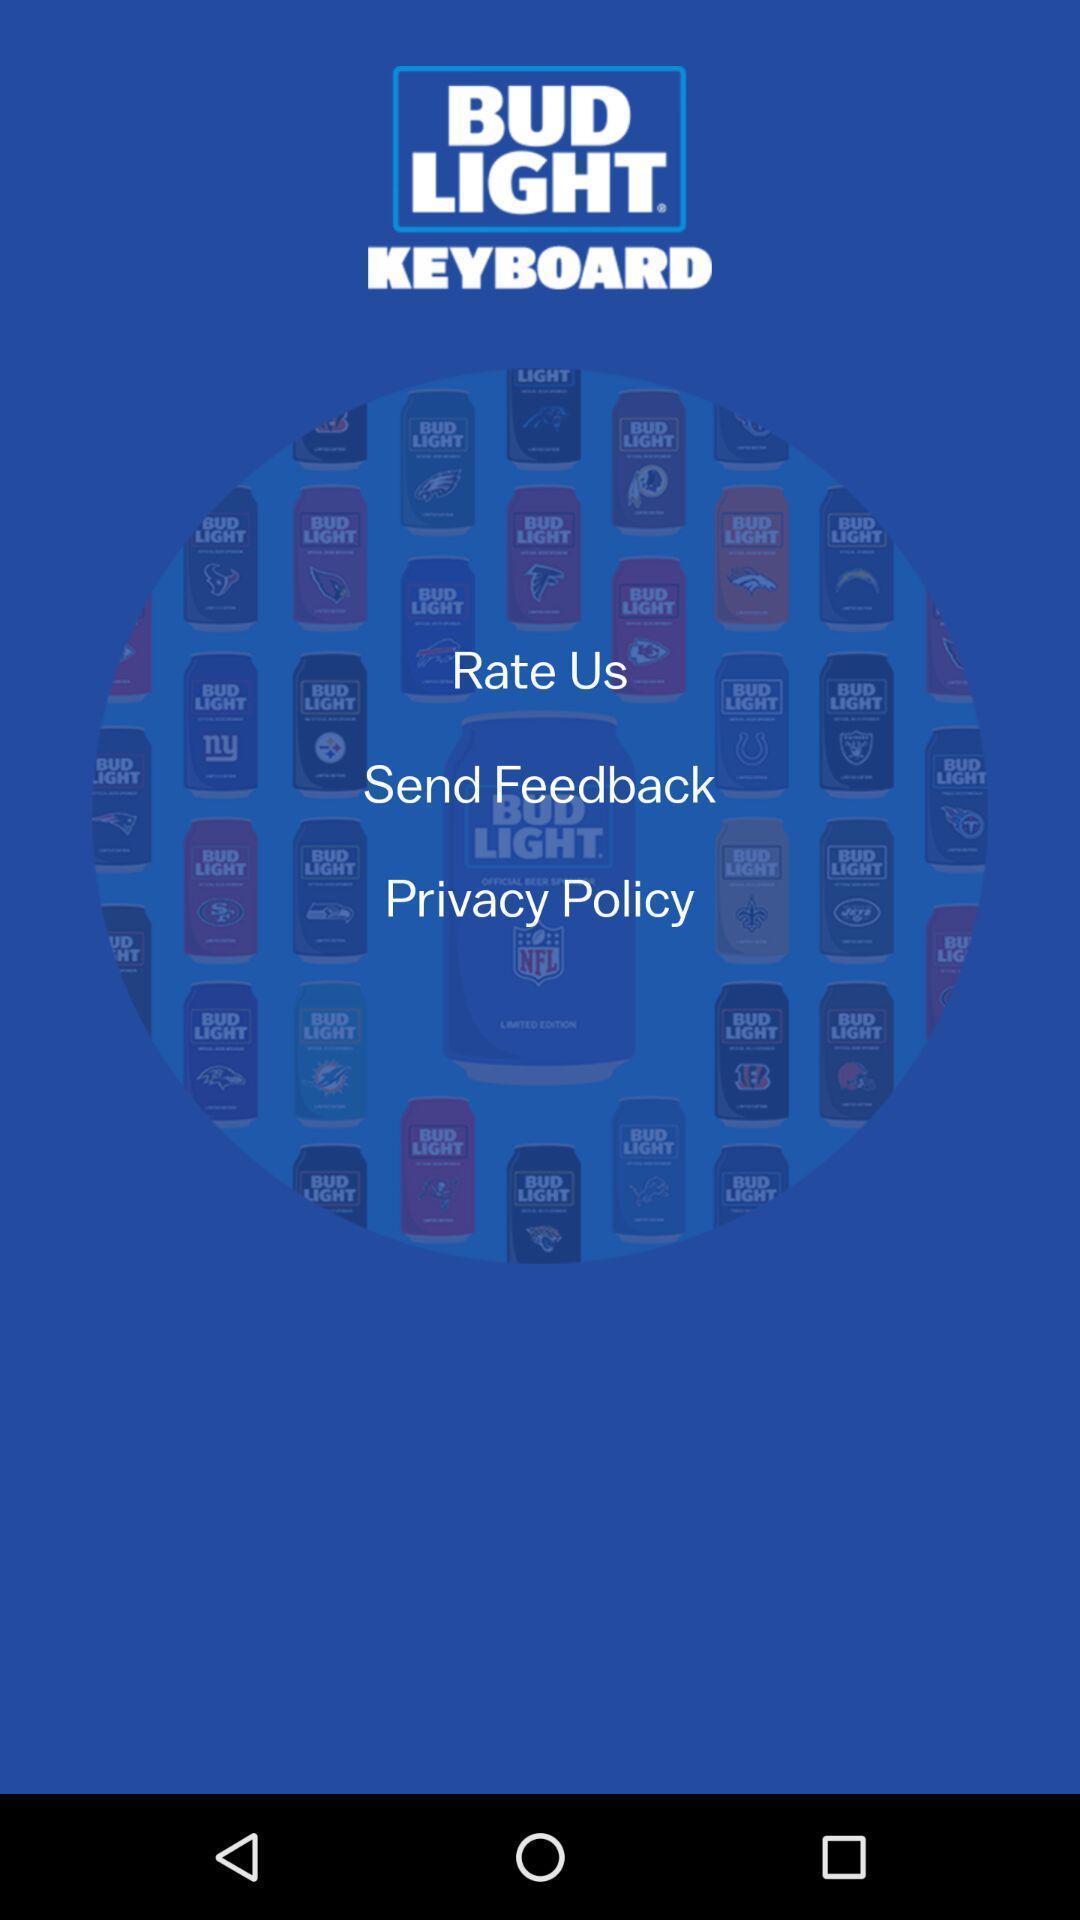Provide a detailed account of this screenshot. Welcome page of a business app. 